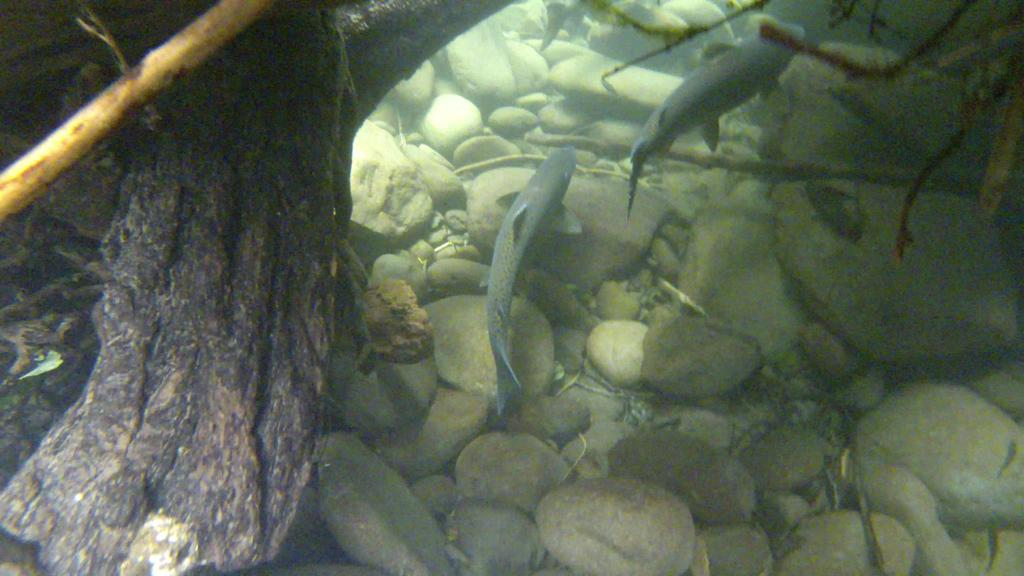Where was the image taken? The image is taken inside the water. What can be seen swimming in the water? There are two fishes in the image. What is visible at the bottom of the image? There are stones at the bottom of the image. What type of mint plant can be seen growing in the image? There is no mint plant present in the image; it is taken inside the water and features two fishes and stones at the bottom. 